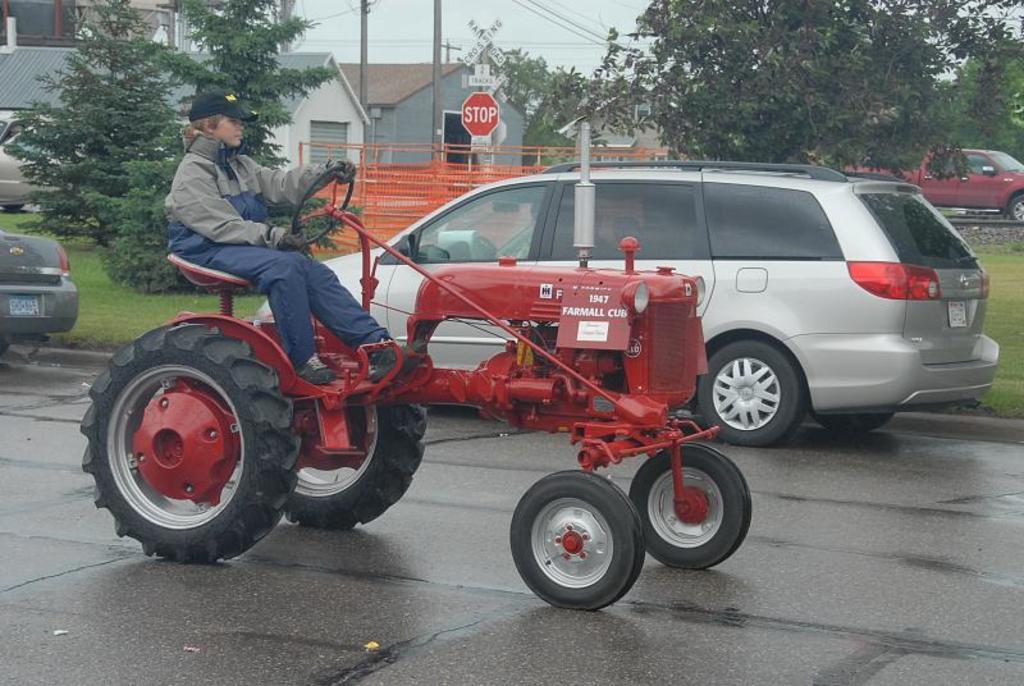Could you give a brief overview of what you see in this image? In this image there is a person sitting on tractor on the road, there are two vehicles visible on the road, at the top there are some buildings, the sky, trees, vehicles , sign boards, poles, cable wires visible. 